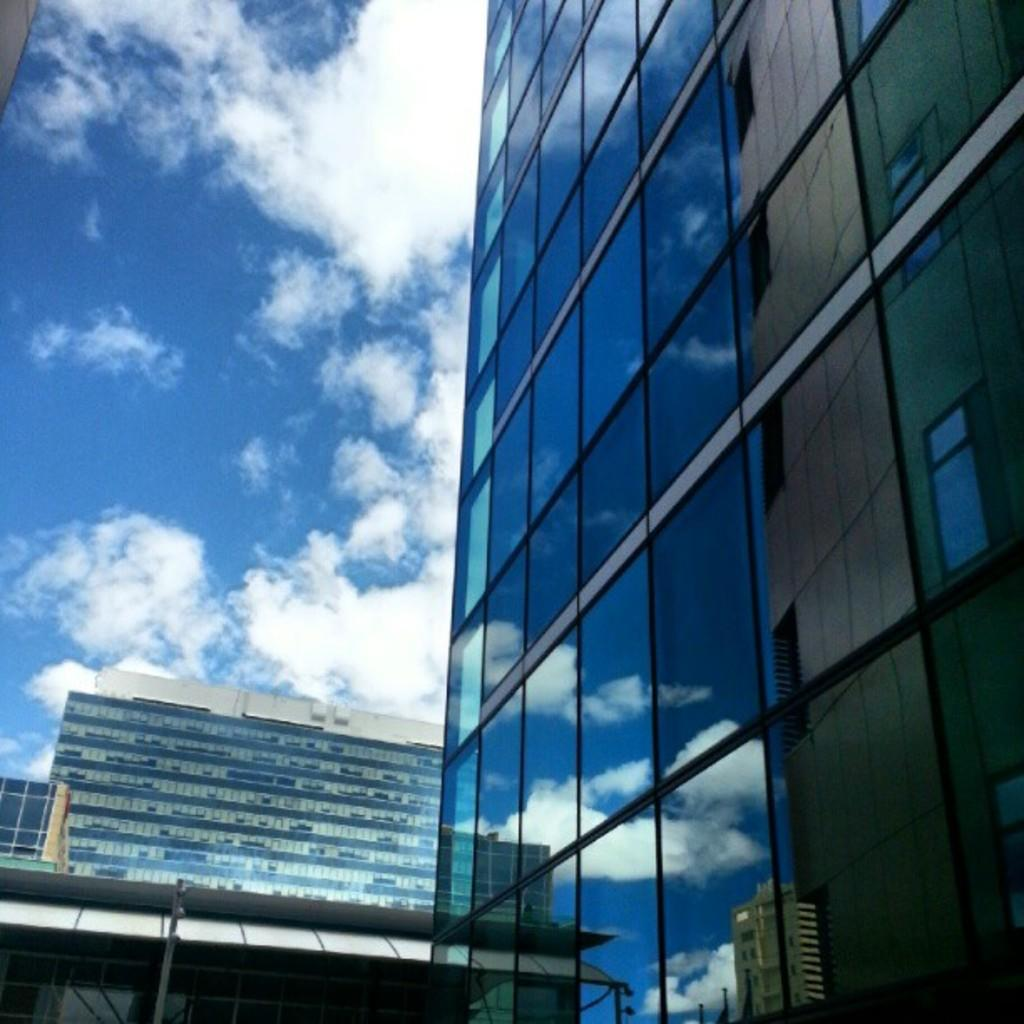What type of structures can be seen in the image? There are buildings in the image. What part of the natural environment is visible in the image? The sky is visible in the image. How would you describe the sky in the image? The sky appears to be cloudy. What is the average income of the people living in the buildings in the image? There is no information about the income of the people living in the buildings in the image. --- 